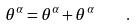<formula> <loc_0><loc_0><loc_500><loc_500>\theta ^ { \alpha } = \theta ^ { \alpha } + \theta ^ { \alpha } \quad .</formula> 